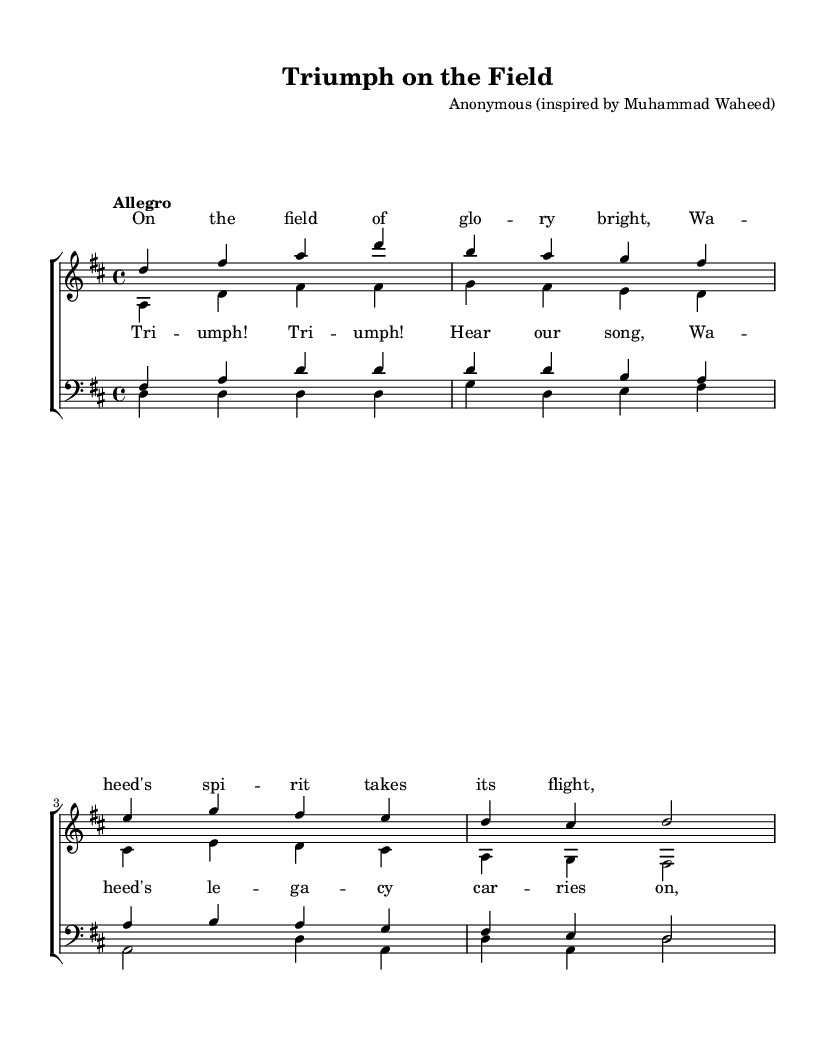What is the key signature of this music? The key signature is D major, which has two sharps (F# and C#). This can be identified by looking at the key signature symbol at the beginning of the staff.
Answer: D major What is the time signature of this piece? The time signature is 4/4, as indicated at the beginning of the score. This means there are four beats in a measure and the quarter note gets one beat.
Answer: 4/4 What is the tempo marking for this score? The tempo marking is "Allegro," which is written above the staff. This indicates a fast and lively tempo.
Answer: Allegro How many voices are in the choral arrangement? There are four voices in the choral arrangement: sopranos, altos, tenors, and basses. This can be determined by observing the distinct parts labeled in the choir staff.
Answer: Four What do the lyrics in the verse celebrate? The lyrics in the verse celebrate athletic glory and the spirit of Waheed, indicating a theme of triumph and inspiration. This can be inferred from the words used in the lyrics provided above the musical notes.
Answer: Athletic glory Which musical form is primarily used in this piece? The musical form primarily used in this piece is a chorus, as indicated by the section labeled "chorus" where the collective voices come together to sing the main theme.
Answer: Chorus What is the motif in the lyrics for the chorus? The motif in the lyrics for the chorus is triumph, as repeated in the phrase "Triumph! Triumph!" This emphasizes a celebration of victories and is a central theme of the piece.
Answer: Triumph 